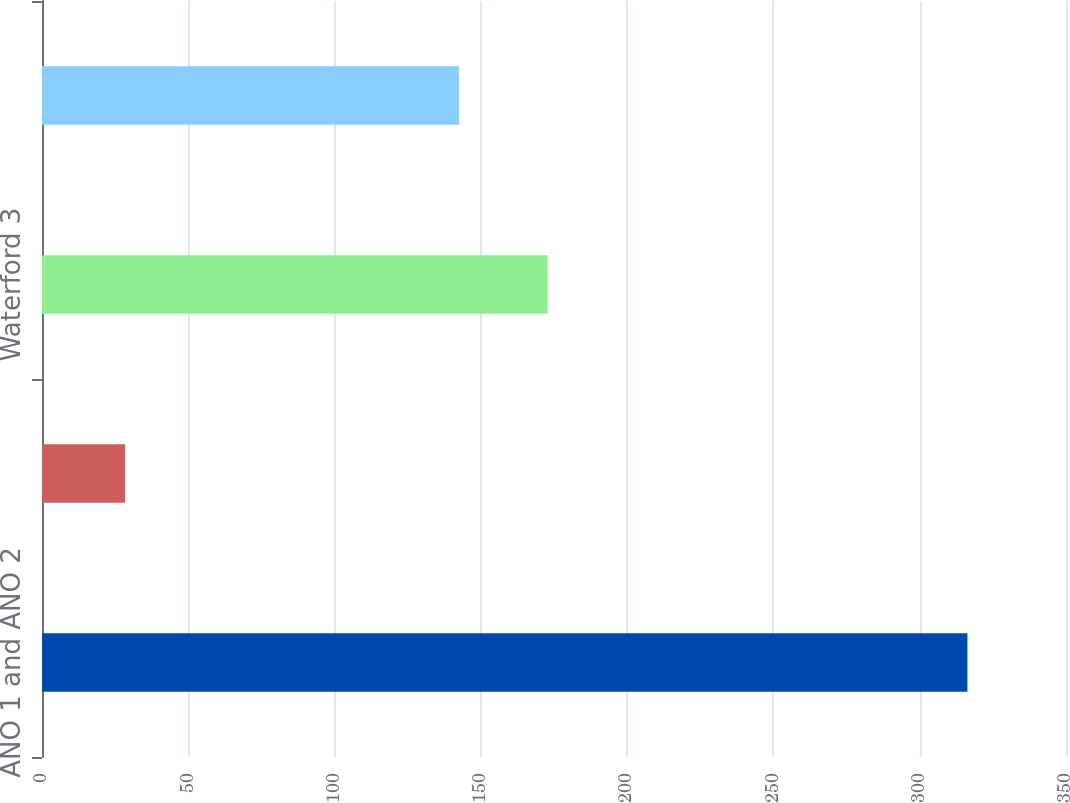Convert chart to OTSL. <chart><loc_0><loc_0><loc_500><loc_500><bar_chart><fcel>ANO 1 and ANO 2<fcel>River Bend<fcel>Waterford 3<fcel>Grand Gulf<nl><fcel>316.3<fcel>28.4<fcel>172.8<fcel>142.5<nl></chart> 